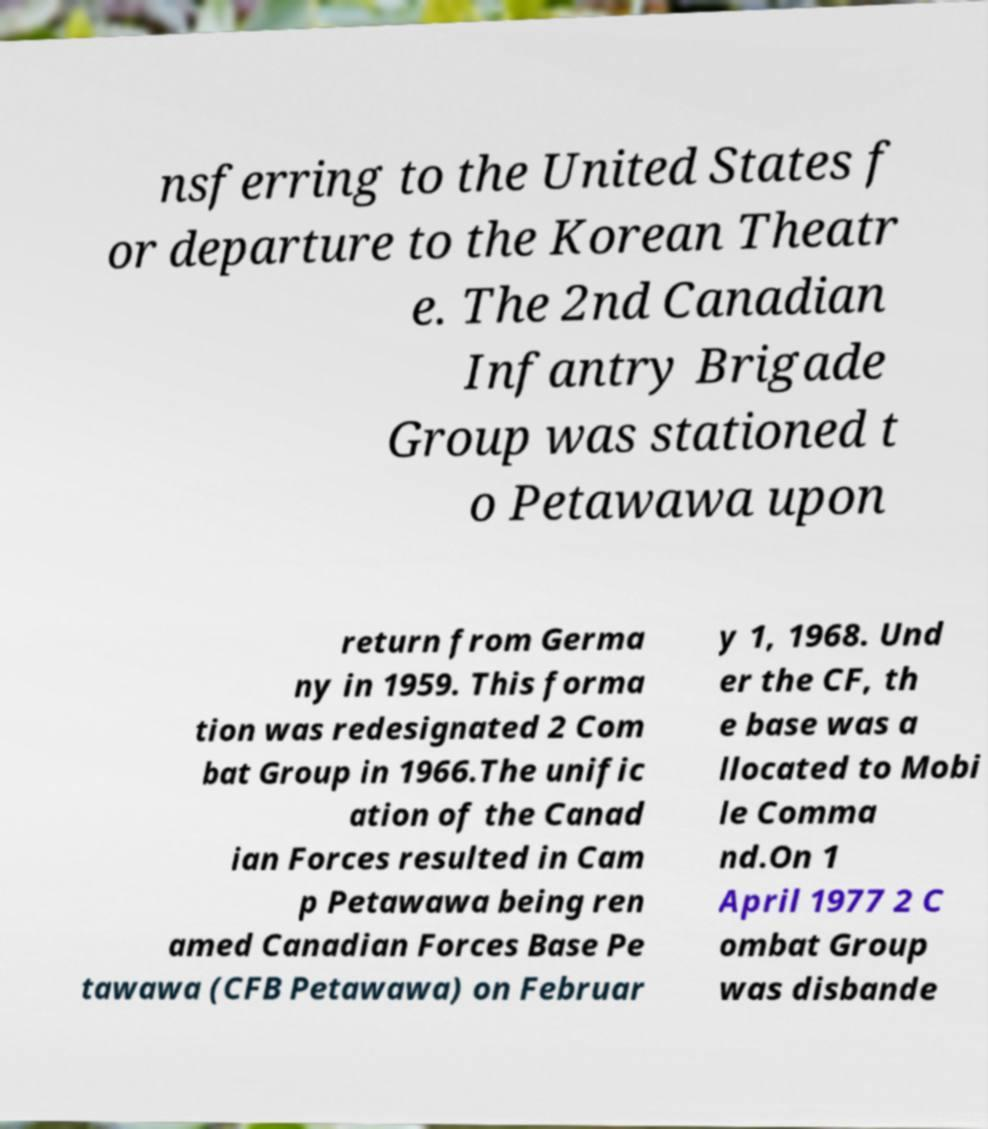There's text embedded in this image that I need extracted. Can you transcribe it verbatim? nsferring to the United States f or departure to the Korean Theatr e. The 2nd Canadian Infantry Brigade Group was stationed t o Petawawa upon return from Germa ny in 1959. This forma tion was redesignated 2 Com bat Group in 1966.The unific ation of the Canad ian Forces resulted in Cam p Petawawa being ren amed Canadian Forces Base Pe tawawa (CFB Petawawa) on Februar y 1, 1968. Und er the CF, th e base was a llocated to Mobi le Comma nd.On 1 April 1977 2 C ombat Group was disbande 